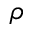<formula> <loc_0><loc_0><loc_500><loc_500>\rho</formula> 